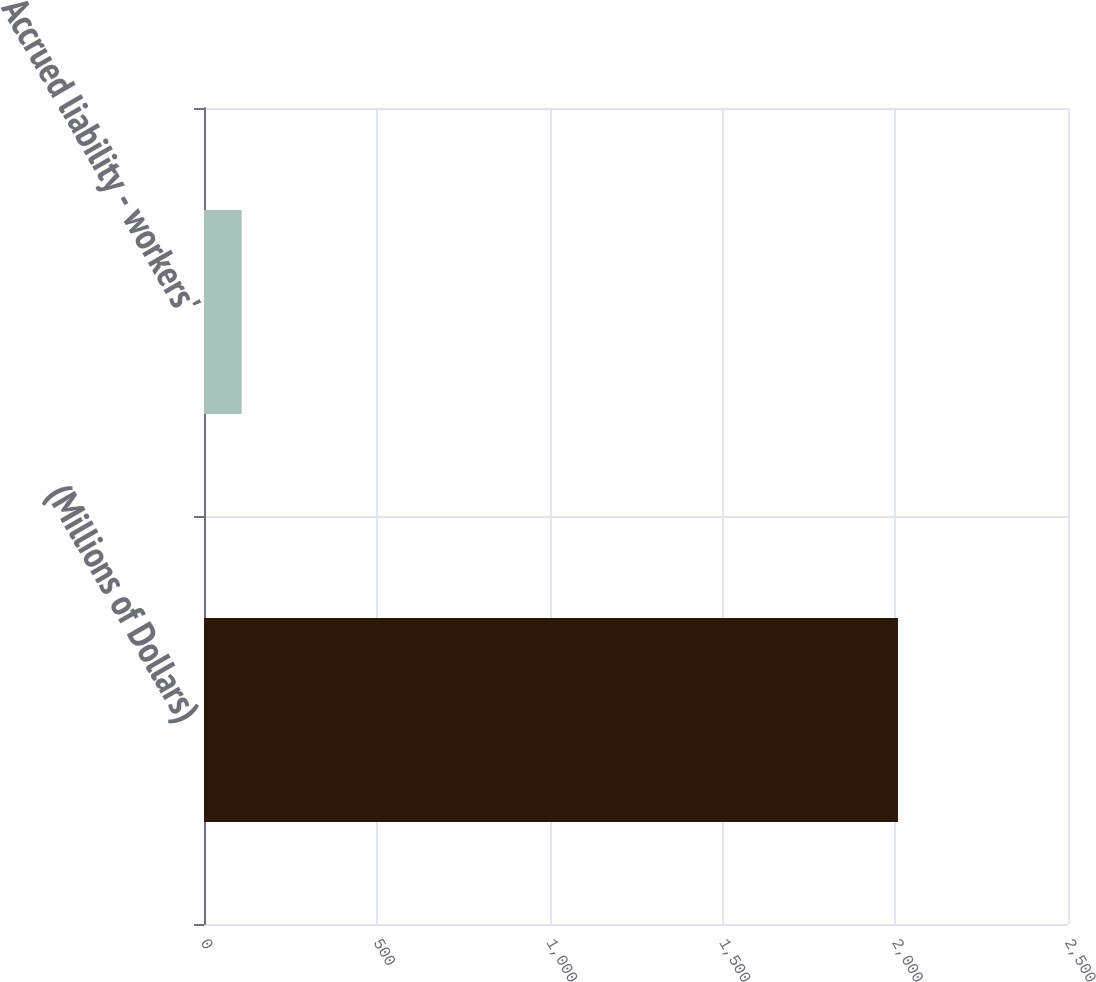Convert chart. <chart><loc_0><loc_0><loc_500><loc_500><bar_chart><fcel>(Millions of Dollars)<fcel>Accrued liability - workers'<nl><fcel>2008<fcel>109<nl></chart> 